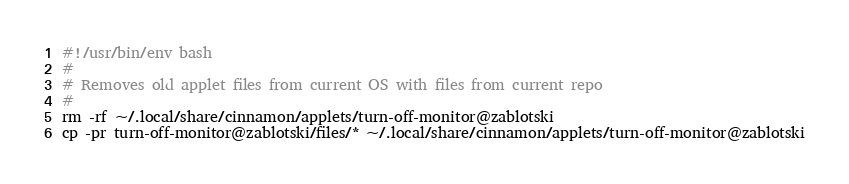<code> <loc_0><loc_0><loc_500><loc_500><_Bash_>#!/usr/bin/env bash
#
# Removes old applet files from current OS with files from current repo
#
rm -rf ~/.local/share/cinnamon/applets/turn-off-monitor@zablotski
cp -pr turn-off-monitor@zablotski/files/* ~/.local/share/cinnamon/applets/turn-off-monitor@zablotski</code> 